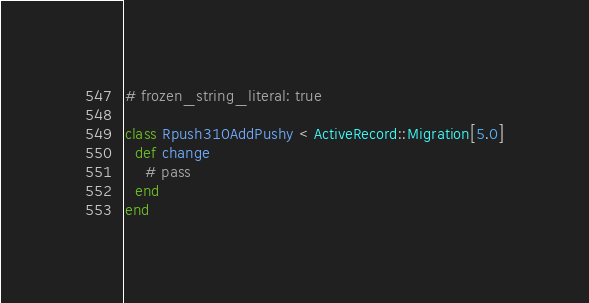Convert code to text. <code><loc_0><loc_0><loc_500><loc_500><_Ruby_># frozen_string_literal: true

class Rpush310AddPushy < ActiveRecord::Migration[5.0]
  def change
    # pass
  end
end
</code> 